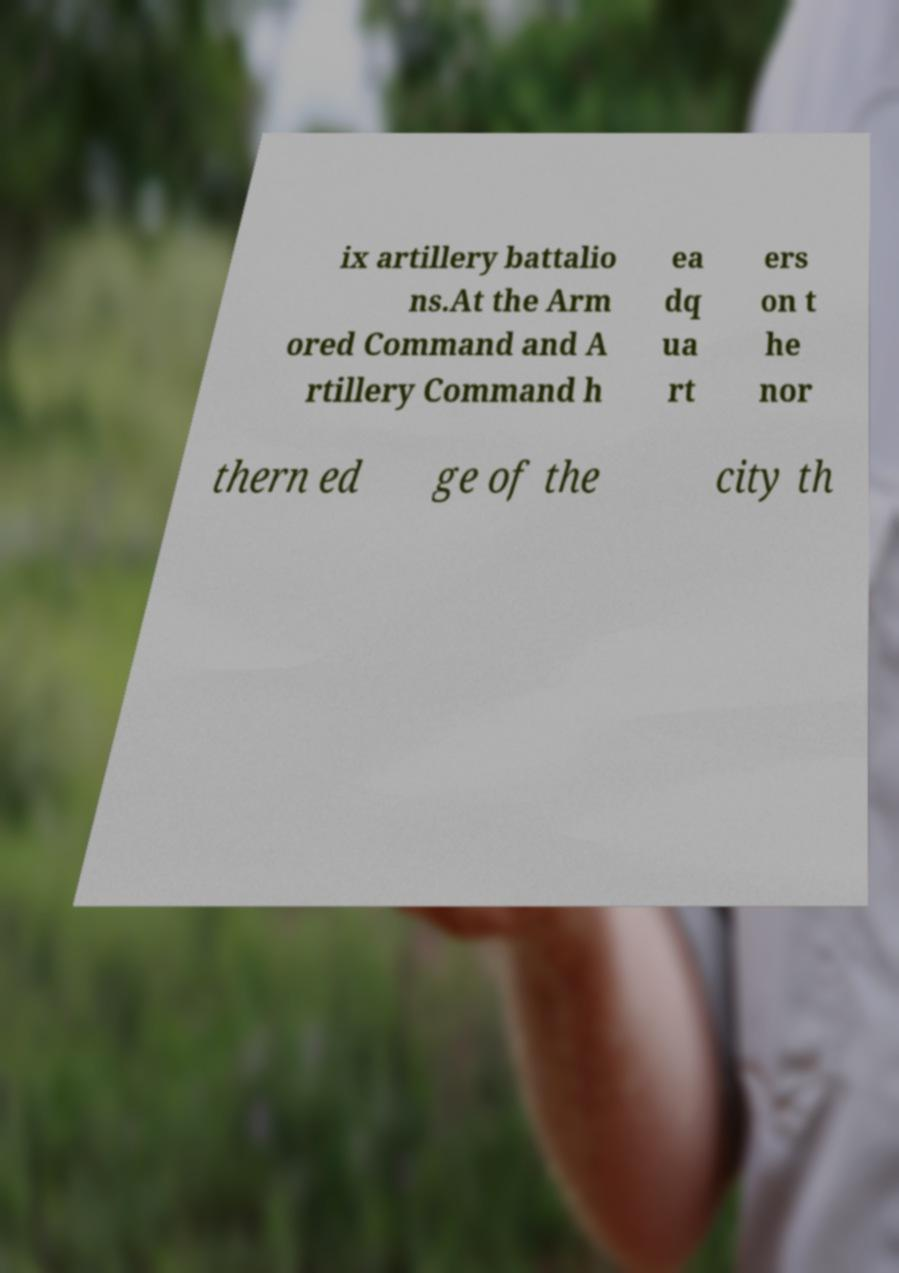For documentation purposes, I need the text within this image transcribed. Could you provide that? ix artillery battalio ns.At the Arm ored Command and A rtillery Command h ea dq ua rt ers on t he nor thern ed ge of the city th 